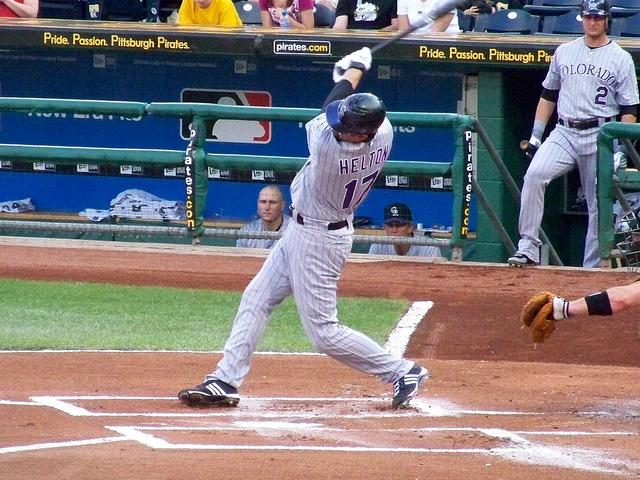Which city is the team in gray from? Please explain your reasoning. colorado. The gray baseball team is from co based on the name on their uniforms. 